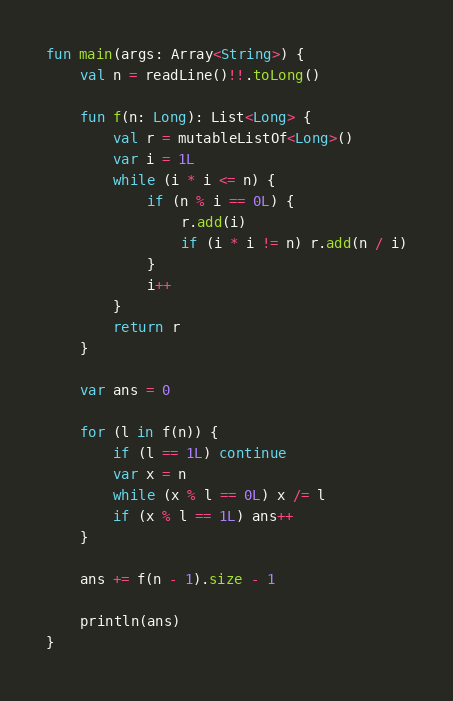<code> <loc_0><loc_0><loc_500><loc_500><_Kotlin_>fun main(args: Array<String>) {
    val n = readLine()!!.toLong()

    fun f(n: Long): List<Long> {
        val r = mutableListOf<Long>()
        var i = 1L
        while (i * i <= n) {
            if (n % i == 0L) {
                r.add(i)
                if (i * i != n) r.add(n / i)
            }
            i++
        }
        return r
    }

    var ans = 0

    for (l in f(n)) {
        if (l == 1L) continue
        var x = n
        while (x % l == 0L) x /= l
        if (x % l == 1L) ans++
    }

    ans += f(n - 1).size - 1

    println(ans)
}
</code> 